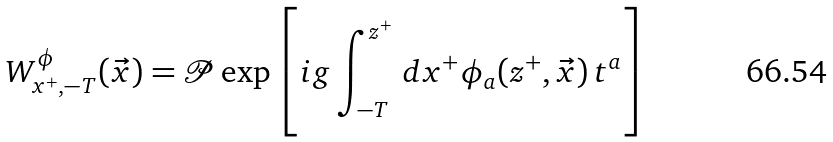Convert formula to latex. <formula><loc_0><loc_0><loc_500><loc_500>W ^ { \phi } _ { x ^ { + } , - T } ( \vec { x } ) = \mathcal { P } \exp \left [ i g \int _ { - T } ^ { z ^ { + } } \, d x ^ { + } \phi _ { a } ( z ^ { + } , \vec { x } ) \, t ^ { a } \right ]</formula> 